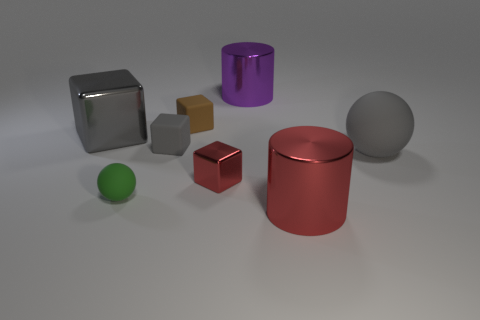Subtract all gray balls. Subtract all red cylinders. How many balls are left? 1 Add 1 gray balls. How many objects exist? 9 Subtract all spheres. How many objects are left? 6 Subtract 2 gray cubes. How many objects are left? 6 Subtract all large purple cylinders. Subtract all tiny green objects. How many objects are left? 6 Add 5 green rubber spheres. How many green rubber spheres are left? 6 Add 7 tiny green matte objects. How many tiny green matte objects exist? 8 